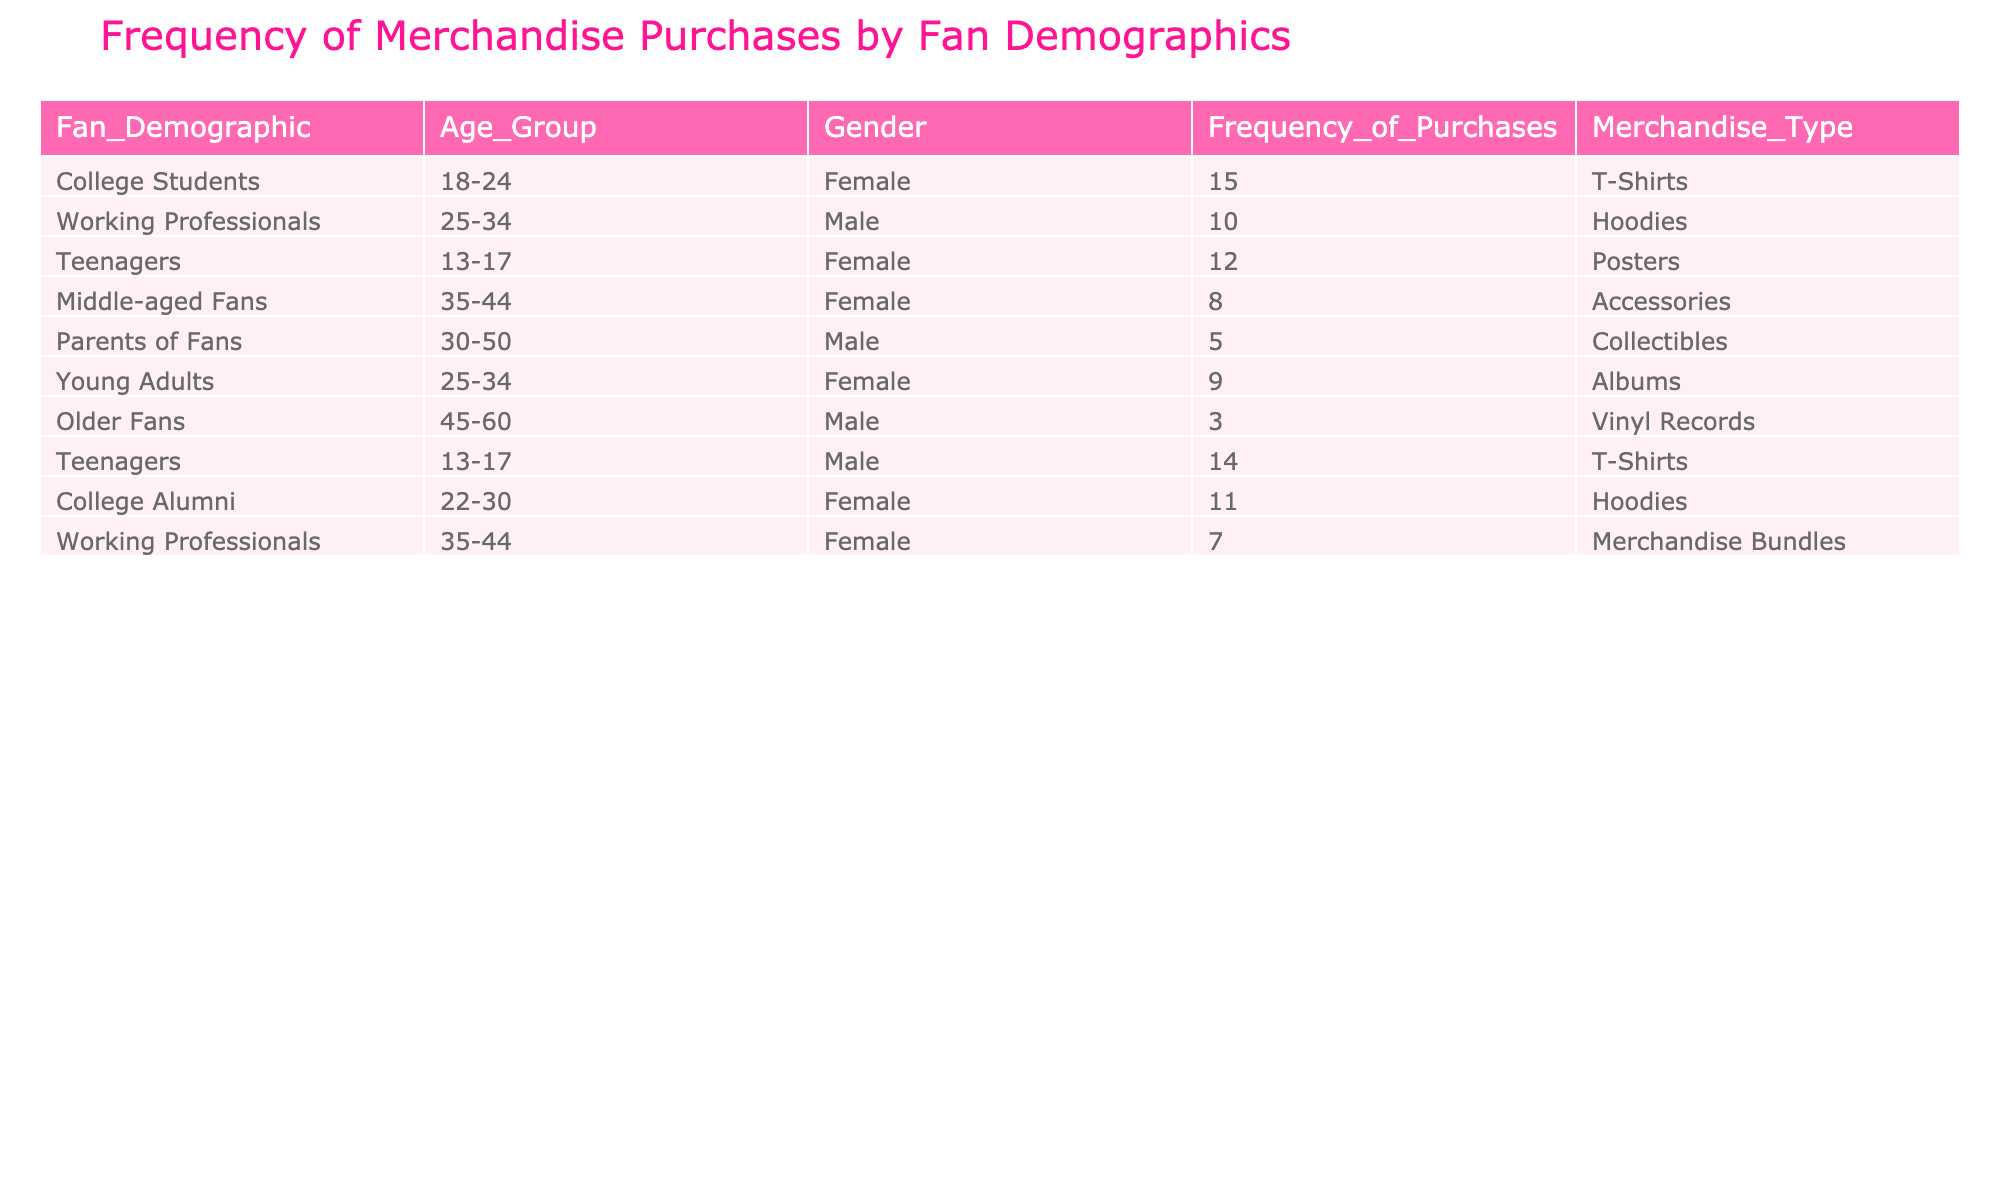What is the total frequency of merchandise purchases made by female fans? To find the total frequency for female fans, we look at the rows where the Gender is "Female." The frequencies are 15, 12, 8, 9, and 7. We sum these values: 15 + 12 + 8 + 9 + 7 = 51.
Answer: 51 Which merchandise type has the highest frequency of purchases among college students? There is one entry for college students with the merchandise type "T-Shirts" and a frequency of 15. Since there are no other entries listed for college students, this is the highest frequency for this demographic.
Answer: T-Shirts What is the difference in the frequency of purchases between male teenagers and male older fans? The frequency of purchases for male teenagers is 14, while for male older fans it is 3. To find the difference, we subtract: 14 - 3 = 11.
Answer: 11 Are there more purchases of Hoodies than Albums among young adults? Looking at the data, young adults purchase Hoodies with a frequency of 9 and Albums are not listed for young adults. Since 9 is greater than 0 (no purchases of Albums are listed), we answer yes.
Answer: Yes What is the average frequency of purchases among middle-aged fans and parents of fans combined? Middle-aged fans have a frequency of 8, while parents of fans have a frequency of 5. To find the average, we add the two frequencies: 8 + 5 = 13, and then divide by 2 (the number of groups): 13 / 2 = 6.5.
Answer: 6.5 Which age group has the lowest frequency of merchandise purchases? The row for "Older Fans" shows 3 purchases, which is lower than all other entries. Looking through the table, no other age group has a frequency lower than 3.
Answer: Older Fans Is there any merchandise type that has the same frequency of purchases among different demographics? Yes, there are two instances of frequency 15 for T-Shirts (one for female college students and one for male teenagers), indicating two demographics purchased the same type with the same frequency.
Answer: Yes How many total merchandise purchases were made by working professionals? There are two entries for working professionals, with frequencies of 10 and 7. To find the total, we sum these frequencies: 10 + 7 = 17.
Answer: 17 